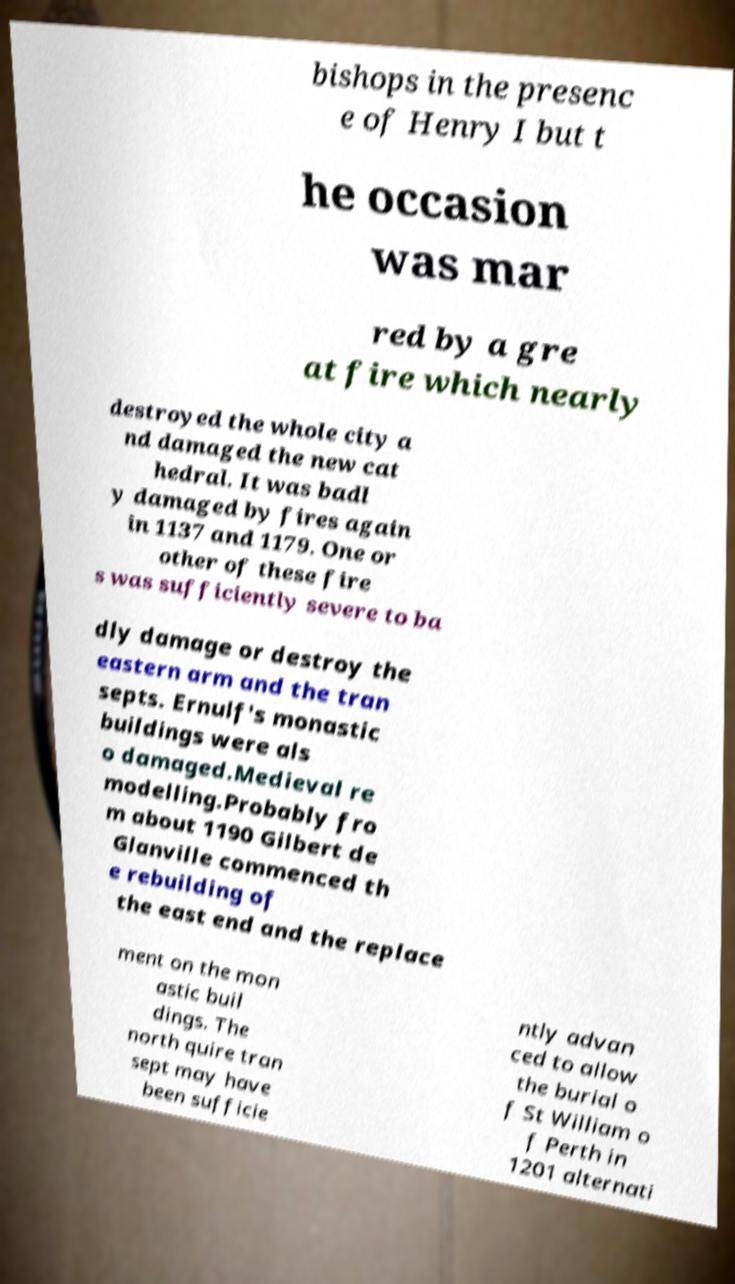There's text embedded in this image that I need extracted. Can you transcribe it verbatim? bishops in the presenc e of Henry I but t he occasion was mar red by a gre at fire which nearly destroyed the whole city a nd damaged the new cat hedral. It was badl y damaged by fires again in 1137 and 1179. One or other of these fire s was sufficiently severe to ba dly damage or destroy the eastern arm and the tran septs. Ernulf's monastic buildings were als o damaged.Medieval re modelling.Probably fro m about 1190 Gilbert de Glanville commenced th e rebuilding of the east end and the replace ment on the mon astic buil dings. The north quire tran sept may have been sufficie ntly advan ced to allow the burial o f St William o f Perth in 1201 alternati 